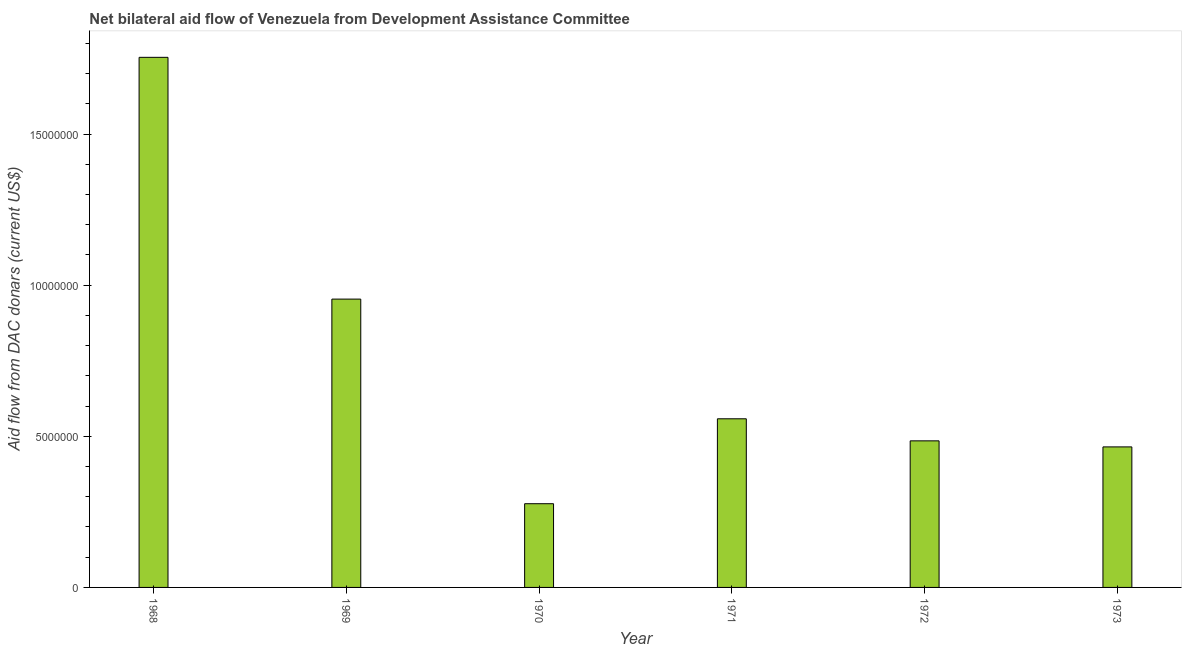Does the graph contain grids?
Provide a succinct answer. No. What is the title of the graph?
Offer a very short reply. Net bilateral aid flow of Venezuela from Development Assistance Committee. What is the label or title of the X-axis?
Keep it short and to the point. Year. What is the label or title of the Y-axis?
Provide a short and direct response. Aid flow from DAC donars (current US$). What is the net bilateral aid flows from dac donors in 1972?
Offer a very short reply. 4.85e+06. Across all years, what is the maximum net bilateral aid flows from dac donors?
Offer a terse response. 1.75e+07. Across all years, what is the minimum net bilateral aid flows from dac donors?
Offer a terse response. 2.77e+06. In which year was the net bilateral aid flows from dac donors maximum?
Make the answer very short. 1968. In which year was the net bilateral aid flows from dac donors minimum?
Ensure brevity in your answer.  1970. What is the sum of the net bilateral aid flows from dac donors?
Give a very brief answer. 4.49e+07. What is the difference between the net bilateral aid flows from dac donors in 1968 and 1971?
Ensure brevity in your answer.  1.20e+07. What is the average net bilateral aid flows from dac donors per year?
Provide a short and direct response. 7.49e+06. What is the median net bilateral aid flows from dac donors?
Give a very brief answer. 5.22e+06. In how many years, is the net bilateral aid flows from dac donors greater than 1000000 US$?
Provide a short and direct response. 6. What is the ratio of the net bilateral aid flows from dac donors in 1968 to that in 1970?
Keep it short and to the point. 6.33. Is the net bilateral aid flows from dac donors in 1968 less than that in 1972?
Make the answer very short. No. What is the difference between the highest and the second highest net bilateral aid flows from dac donors?
Give a very brief answer. 8.00e+06. What is the difference between the highest and the lowest net bilateral aid flows from dac donors?
Make the answer very short. 1.48e+07. In how many years, is the net bilateral aid flows from dac donors greater than the average net bilateral aid flows from dac donors taken over all years?
Your answer should be compact. 2. How many bars are there?
Offer a terse response. 6. Are all the bars in the graph horizontal?
Keep it short and to the point. No. How many years are there in the graph?
Your answer should be compact. 6. What is the difference between two consecutive major ticks on the Y-axis?
Your answer should be compact. 5.00e+06. What is the Aid flow from DAC donars (current US$) of 1968?
Offer a terse response. 1.75e+07. What is the Aid flow from DAC donars (current US$) of 1969?
Your response must be concise. 9.54e+06. What is the Aid flow from DAC donars (current US$) of 1970?
Your answer should be very brief. 2.77e+06. What is the Aid flow from DAC donars (current US$) in 1971?
Ensure brevity in your answer.  5.58e+06. What is the Aid flow from DAC donars (current US$) of 1972?
Provide a succinct answer. 4.85e+06. What is the Aid flow from DAC donars (current US$) in 1973?
Ensure brevity in your answer.  4.65e+06. What is the difference between the Aid flow from DAC donars (current US$) in 1968 and 1970?
Provide a short and direct response. 1.48e+07. What is the difference between the Aid flow from DAC donars (current US$) in 1968 and 1971?
Give a very brief answer. 1.20e+07. What is the difference between the Aid flow from DAC donars (current US$) in 1968 and 1972?
Keep it short and to the point. 1.27e+07. What is the difference between the Aid flow from DAC donars (current US$) in 1968 and 1973?
Ensure brevity in your answer.  1.29e+07. What is the difference between the Aid flow from DAC donars (current US$) in 1969 and 1970?
Offer a terse response. 6.77e+06. What is the difference between the Aid flow from DAC donars (current US$) in 1969 and 1971?
Your answer should be very brief. 3.96e+06. What is the difference between the Aid flow from DAC donars (current US$) in 1969 and 1972?
Your answer should be very brief. 4.69e+06. What is the difference between the Aid flow from DAC donars (current US$) in 1969 and 1973?
Give a very brief answer. 4.89e+06. What is the difference between the Aid flow from DAC donars (current US$) in 1970 and 1971?
Keep it short and to the point. -2.81e+06. What is the difference between the Aid flow from DAC donars (current US$) in 1970 and 1972?
Make the answer very short. -2.08e+06. What is the difference between the Aid flow from DAC donars (current US$) in 1970 and 1973?
Offer a terse response. -1.88e+06. What is the difference between the Aid flow from DAC donars (current US$) in 1971 and 1972?
Offer a very short reply. 7.30e+05. What is the difference between the Aid flow from DAC donars (current US$) in 1971 and 1973?
Provide a short and direct response. 9.30e+05. What is the difference between the Aid flow from DAC donars (current US$) in 1972 and 1973?
Make the answer very short. 2.00e+05. What is the ratio of the Aid flow from DAC donars (current US$) in 1968 to that in 1969?
Your response must be concise. 1.84. What is the ratio of the Aid flow from DAC donars (current US$) in 1968 to that in 1970?
Your response must be concise. 6.33. What is the ratio of the Aid flow from DAC donars (current US$) in 1968 to that in 1971?
Your answer should be compact. 3.14. What is the ratio of the Aid flow from DAC donars (current US$) in 1968 to that in 1972?
Make the answer very short. 3.62. What is the ratio of the Aid flow from DAC donars (current US$) in 1968 to that in 1973?
Provide a succinct answer. 3.77. What is the ratio of the Aid flow from DAC donars (current US$) in 1969 to that in 1970?
Make the answer very short. 3.44. What is the ratio of the Aid flow from DAC donars (current US$) in 1969 to that in 1971?
Provide a succinct answer. 1.71. What is the ratio of the Aid flow from DAC donars (current US$) in 1969 to that in 1972?
Give a very brief answer. 1.97. What is the ratio of the Aid flow from DAC donars (current US$) in 1969 to that in 1973?
Your answer should be compact. 2.05. What is the ratio of the Aid flow from DAC donars (current US$) in 1970 to that in 1971?
Your answer should be compact. 0.5. What is the ratio of the Aid flow from DAC donars (current US$) in 1970 to that in 1972?
Give a very brief answer. 0.57. What is the ratio of the Aid flow from DAC donars (current US$) in 1970 to that in 1973?
Give a very brief answer. 0.6. What is the ratio of the Aid flow from DAC donars (current US$) in 1971 to that in 1972?
Give a very brief answer. 1.15. What is the ratio of the Aid flow from DAC donars (current US$) in 1971 to that in 1973?
Your answer should be very brief. 1.2. What is the ratio of the Aid flow from DAC donars (current US$) in 1972 to that in 1973?
Provide a short and direct response. 1.04. 